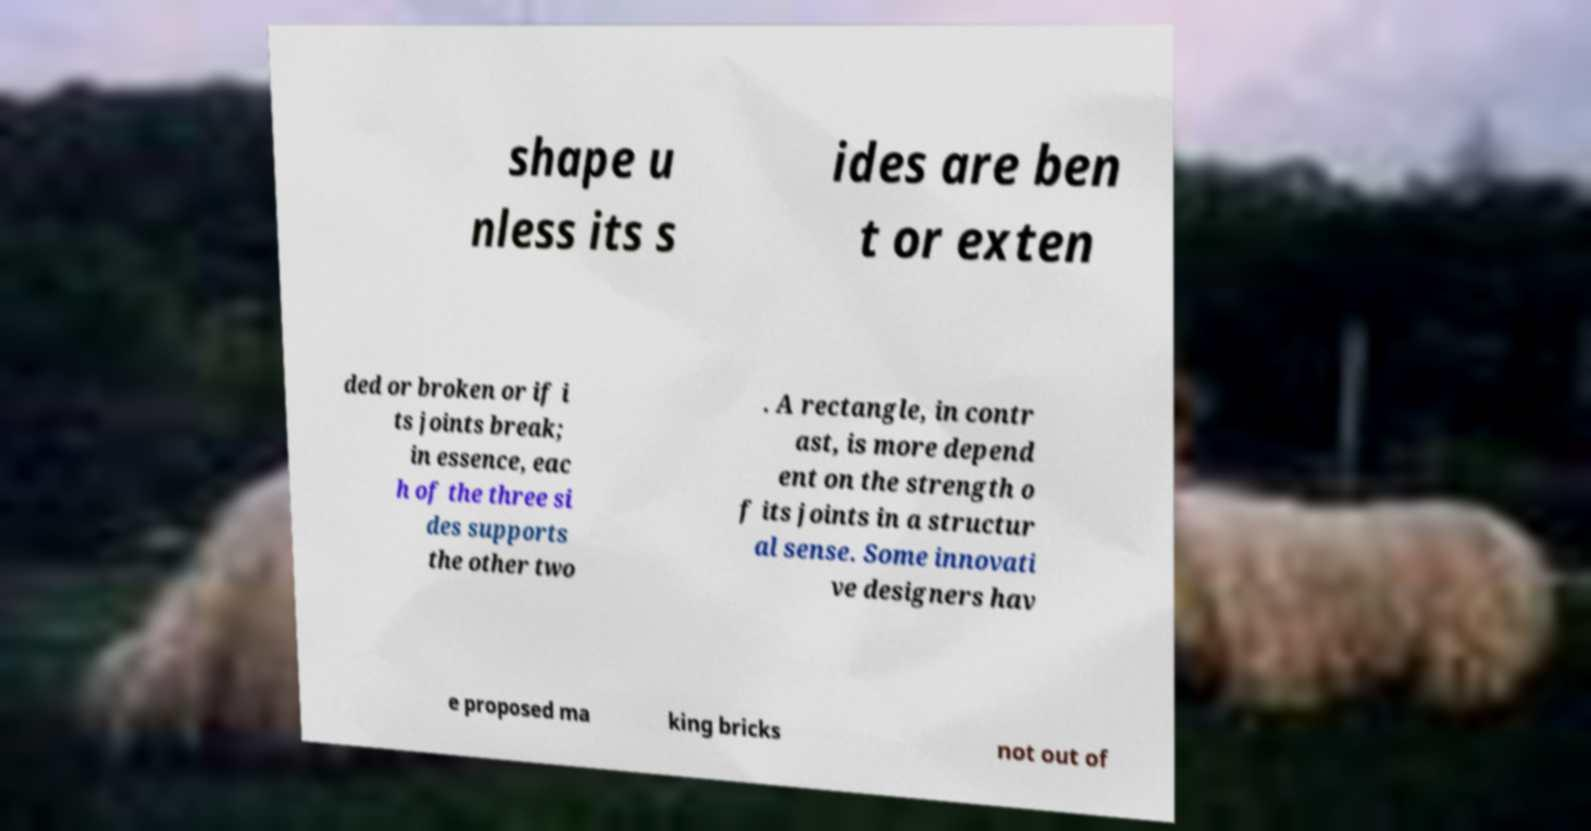There's text embedded in this image that I need extracted. Can you transcribe it verbatim? shape u nless its s ides are ben t or exten ded or broken or if i ts joints break; in essence, eac h of the three si des supports the other two . A rectangle, in contr ast, is more depend ent on the strength o f its joints in a structur al sense. Some innovati ve designers hav e proposed ma king bricks not out of 